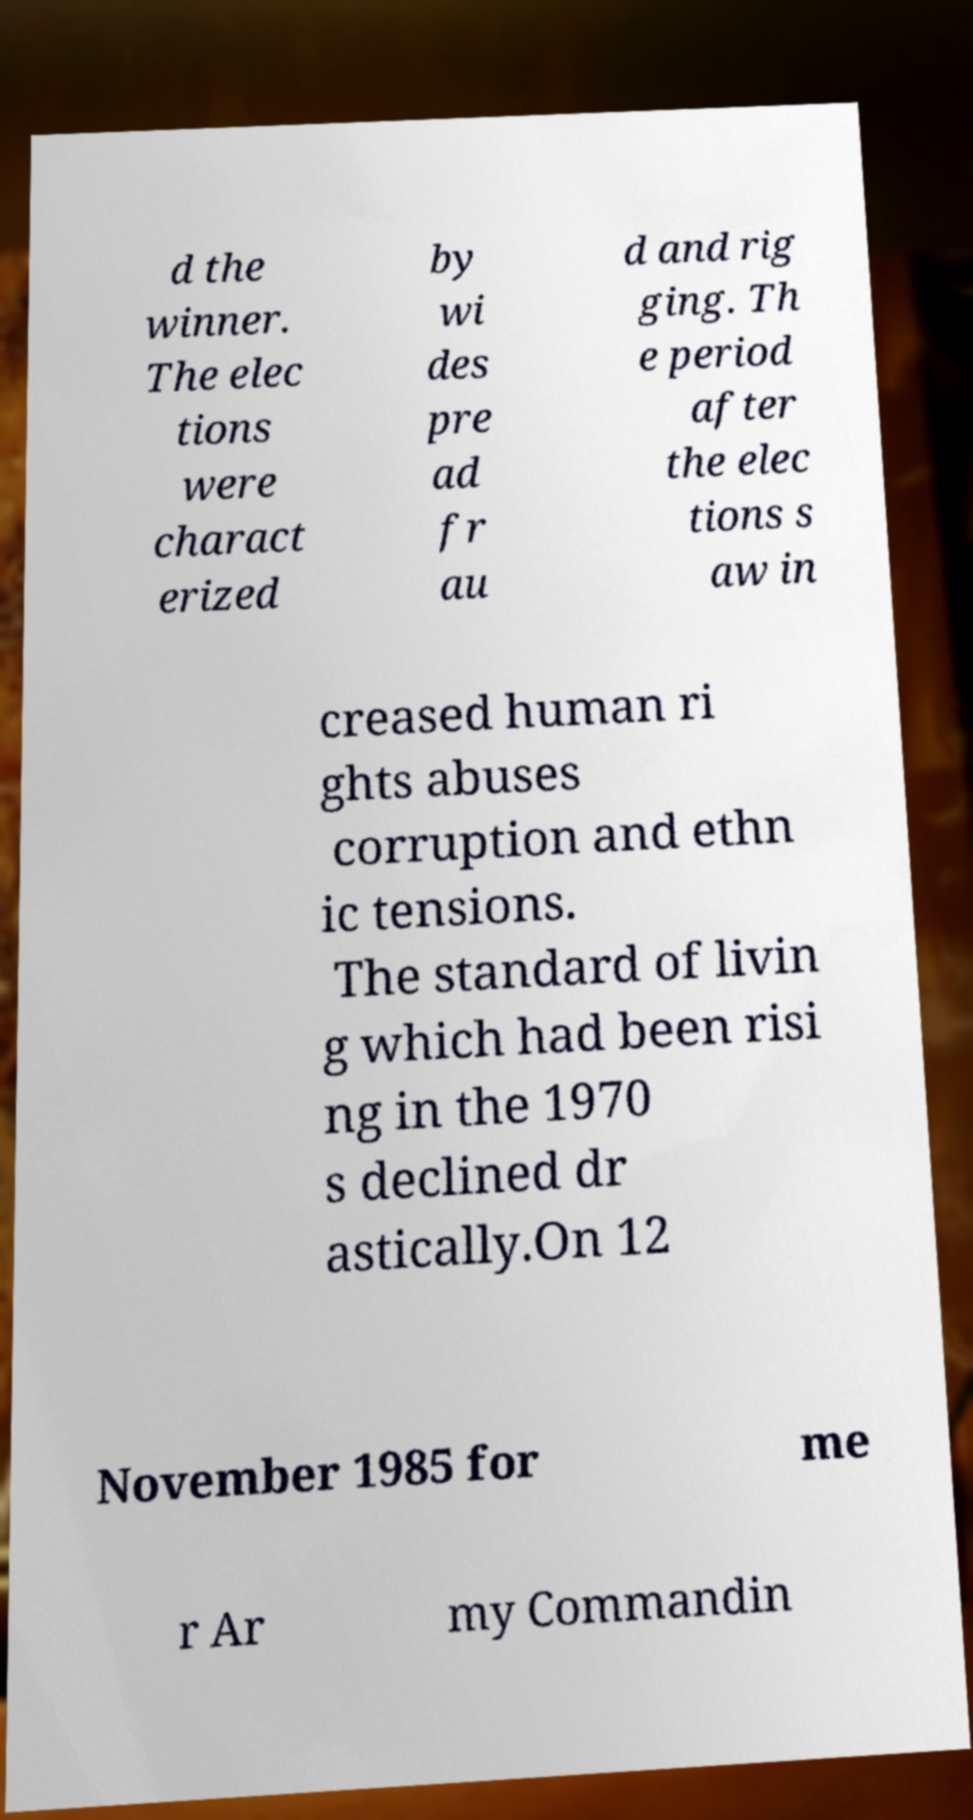Can you read and provide the text displayed in the image?This photo seems to have some interesting text. Can you extract and type it out for me? d the winner. The elec tions were charact erized by wi des pre ad fr au d and rig ging. Th e period after the elec tions s aw in creased human ri ghts abuses corruption and ethn ic tensions. The standard of livin g which had been risi ng in the 1970 s declined dr astically.On 12 November 1985 for me r Ar my Commandin 